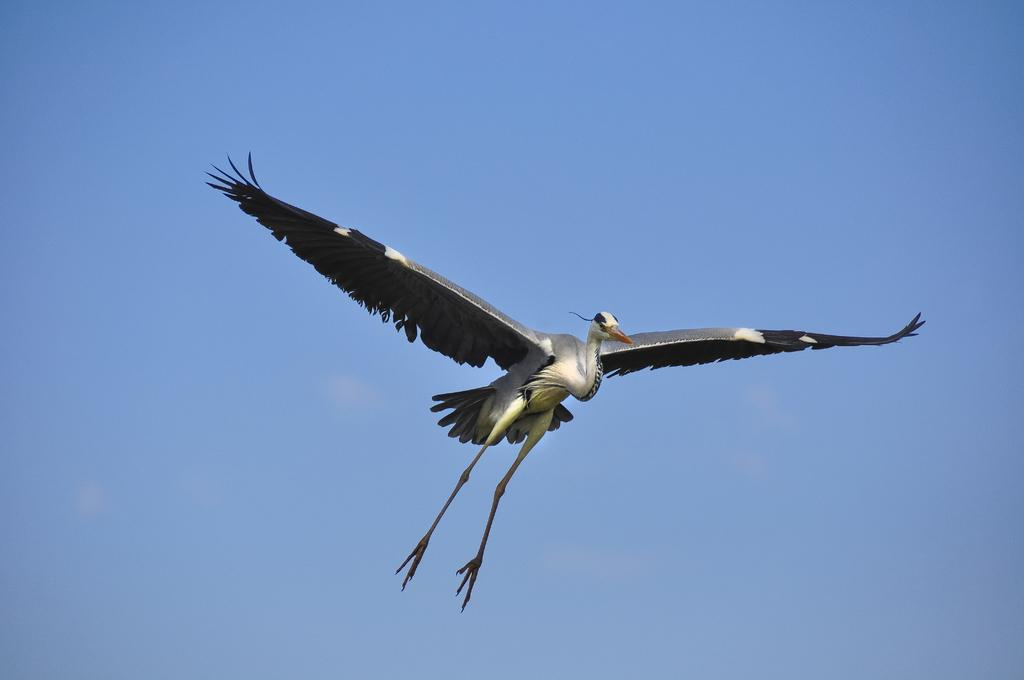What is the main subject of the image? There is a crane in the image. Can you describe the position of the crane? The crane is in the air. What can be seen in the background of the image? There is sky visible in the background of the image. What time of day is it in the image, and how does the crane help with morning routines? The time of day is not mentioned in the image, and there is no indication of the crane helping with morning routines. 